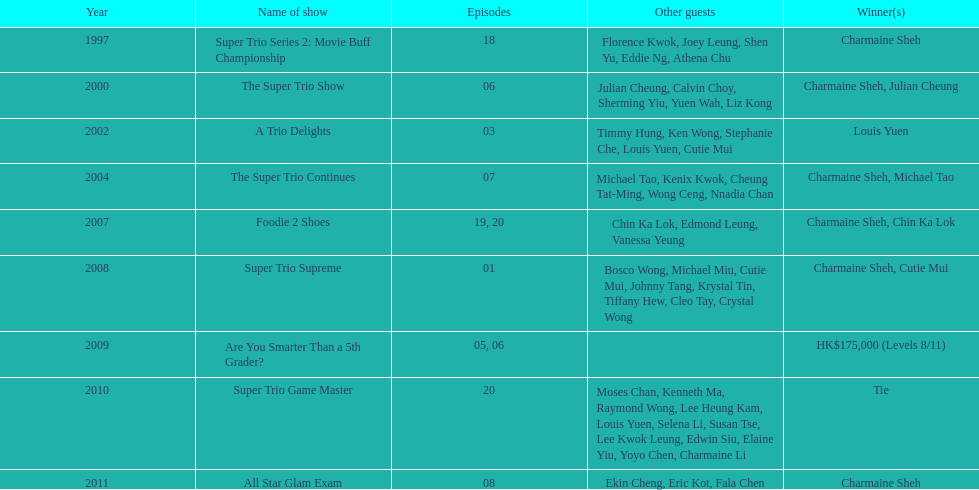For the super trio 2: movie buff champions variety show, how many episodes included charmaine sheh's participation? 18. 